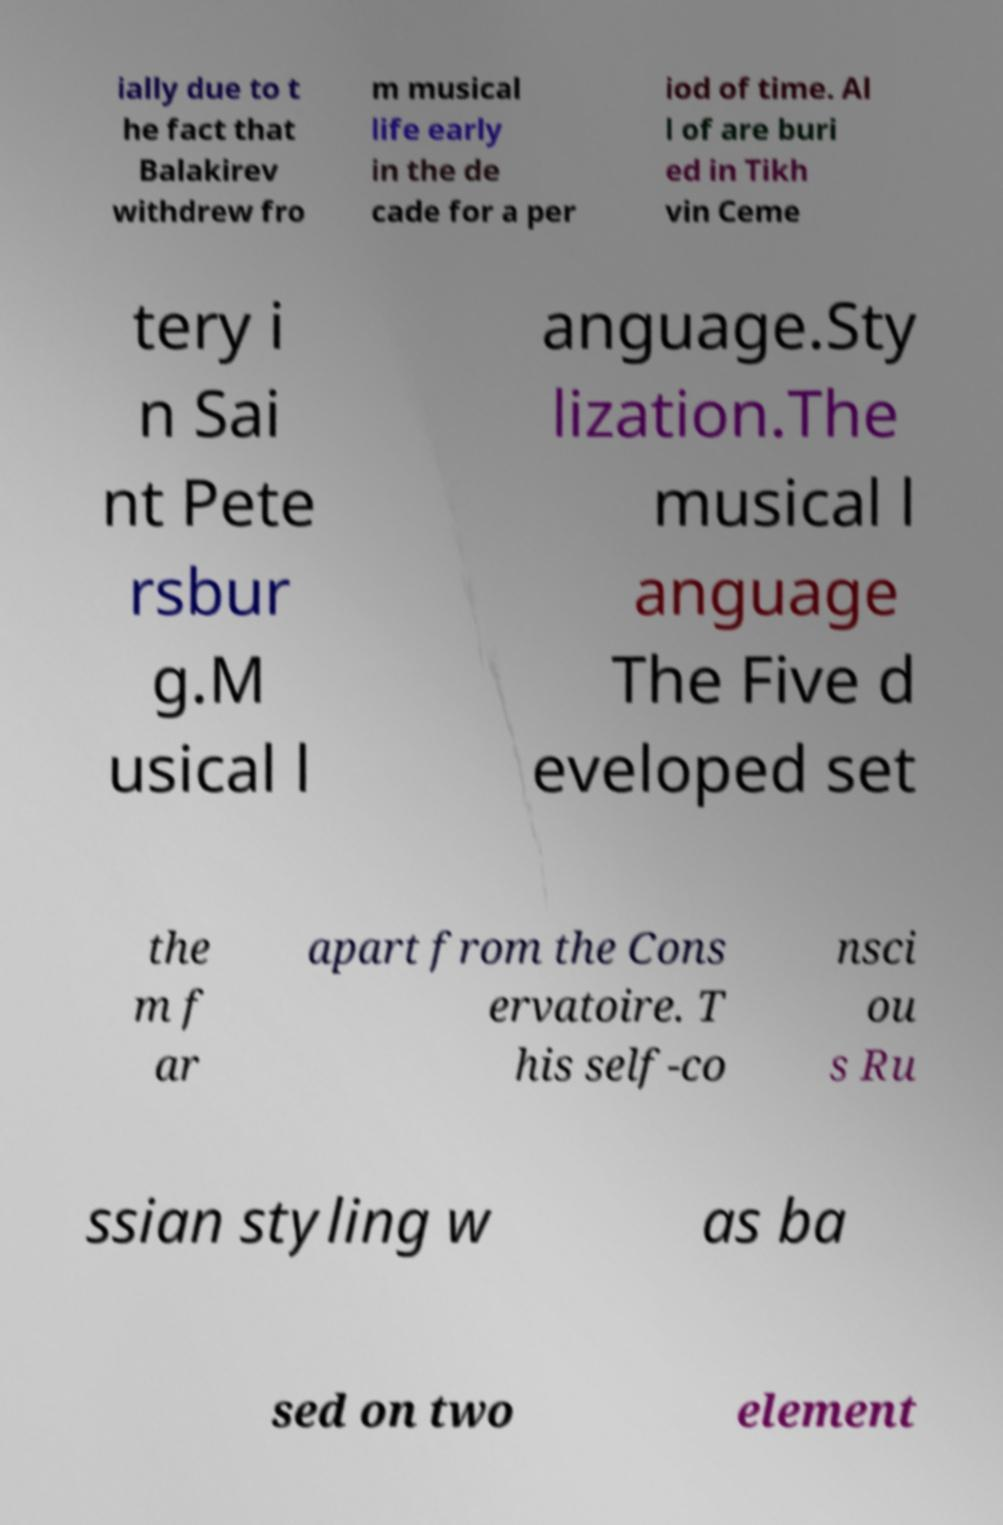I need the written content from this picture converted into text. Can you do that? ially due to t he fact that Balakirev withdrew fro m musical life early in the de cade for a per iod of time. Al l of are buri ed in Tikh vin Ceme tery i n Sai nt Pete rsbur g.M usical l anguage.Sty lization.The musical l anguage The Five d eveloped set the m f ar apart from the Cons ervatoire. T his self-co nsci ou s Ru ssian styling w as ba sed on two element 